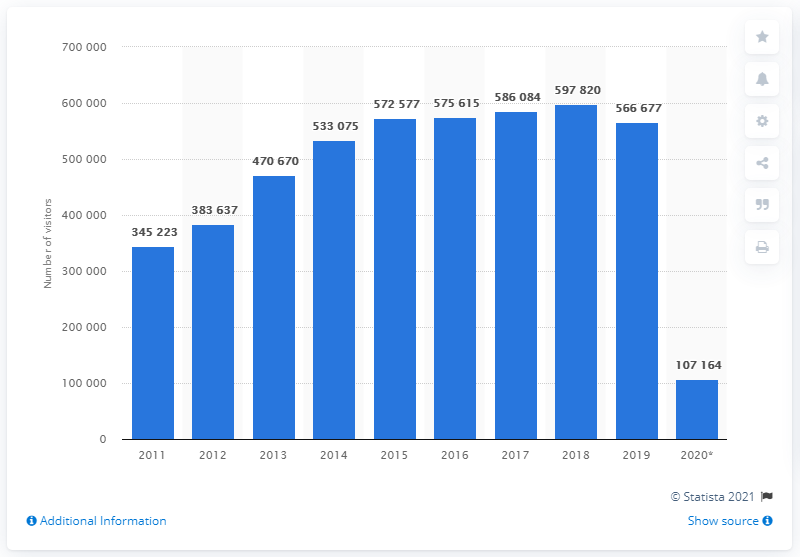Point out several critical features in this image. The total number of visitors from Africa to the United States in 2019 was 566,677. According to the records, in 2020, the United States recorded 107,164 travelers arriving from Africa. 